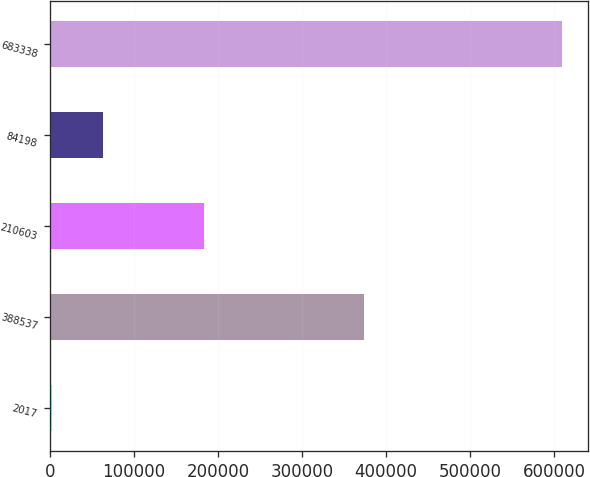<chart> <loc_0><loc_0><loc_500><loc_500><bar_chart><fcel>2017<fcel>388537<fcel>210603<fcel>84198<fcel>683338<nl><fcel>2016<fcel>373860<fcel>182813<fcel>62754<fcel>609396<nl></chart> 